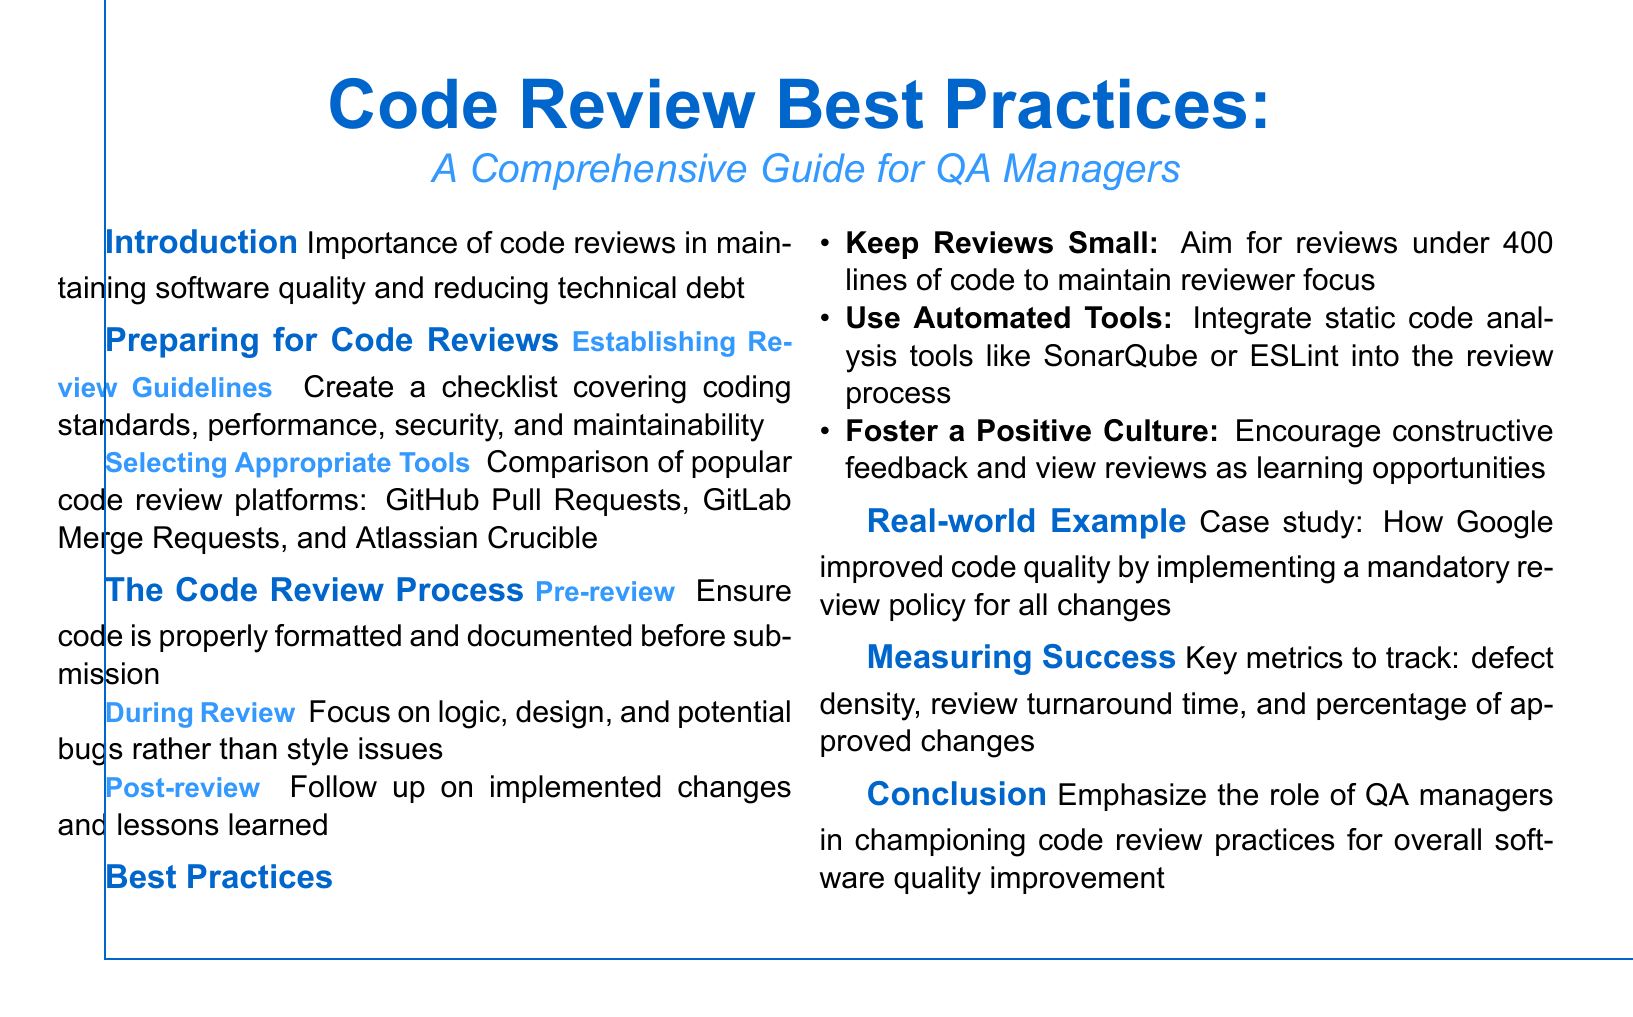What is the main focus of the guide? The guide emphasizes the importance of code reviews in maintaining software quality and reducing technical debt.
Answer: Importance of code reviews What is the recommended maximum number of lines for code reviews? The document suggests keeping reviews under 400 lines of code to maintain reviewer focus.
Answer: 400 lines Which code review platform is mentioned first for comparison? The first platform listed for comparison in the document is GitHub Pull Requests.
Answer: GitHub Pull Requests What key metric is suggested to track the success of code reviews? The document mentions defect density as one of the key metrics to track for measuring success.
Answer: Defect density What case study is referenced in the document? The document references a case study about how Google improved code quality by implementing a mandatory review policy.
Answer: Google 